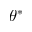<formula> <loc_0><loc_0><loc_500><loc_500>\theta ^ { * }</formula> 